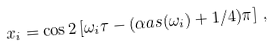<formula> <loc_0><loc_0><loc_500><loc_500>x _ { i } = \cos 2 \left [ \omega _ { i } \tau - ( \alpha a s ( \omega _ { i } ) + 1 / 4 ) \pi \right ] \, ,</formula> 